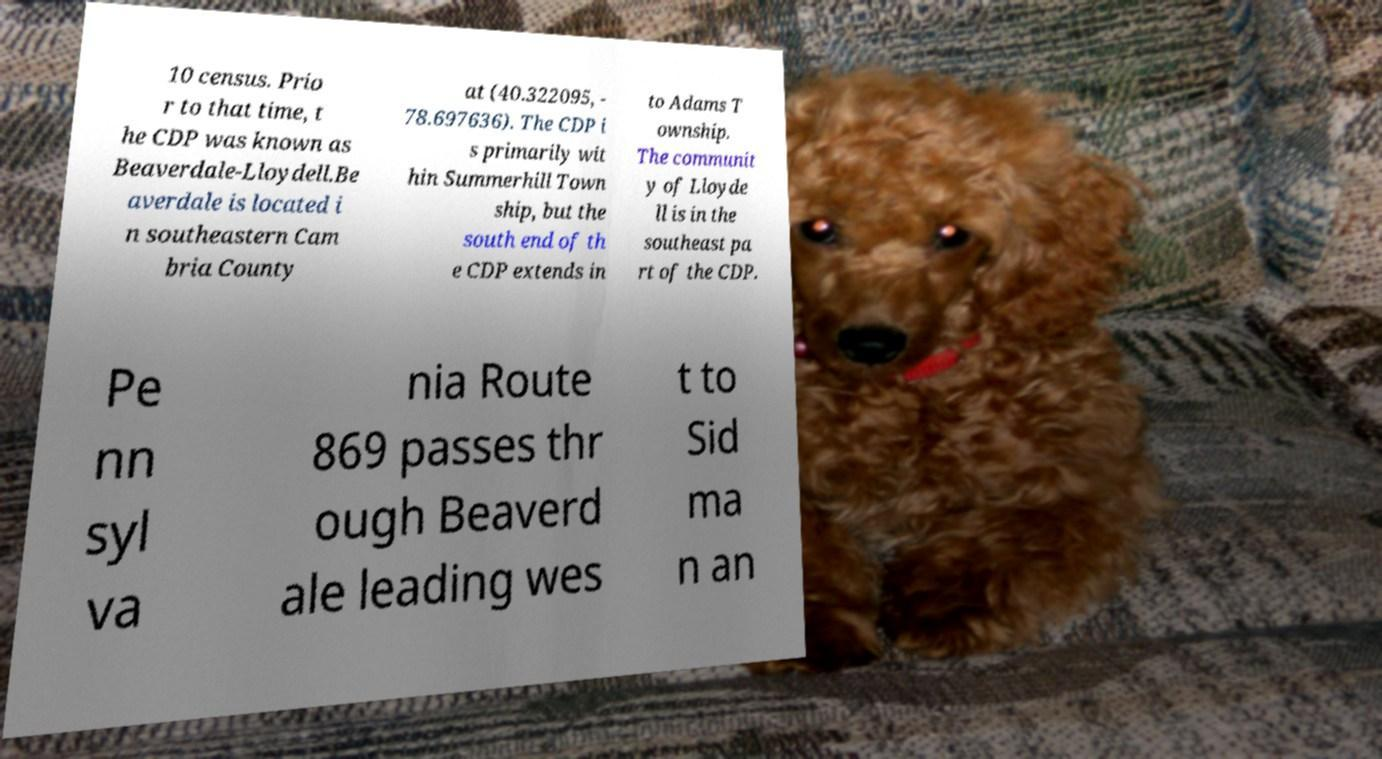There's text embedded in this image that I need extracted. Can you transcribe it verbatim? 10 census. Prio r to that time, t he CDP was known as Beaverdale-Lloydell.Be averdale is located i n southeastern Cam bria County at (40.322095, - 78.697636). The CDP i s primarily wit hin Summerhill Town ship, but the south end of th e CDP extends in to Adams T ownship. The communit y of Lloyde ll is in the southeast pa rt of the CDP. Pe nn syl va nia Route 869 passes thr ough Beaverd ale leading wes t to Sid ma n an 